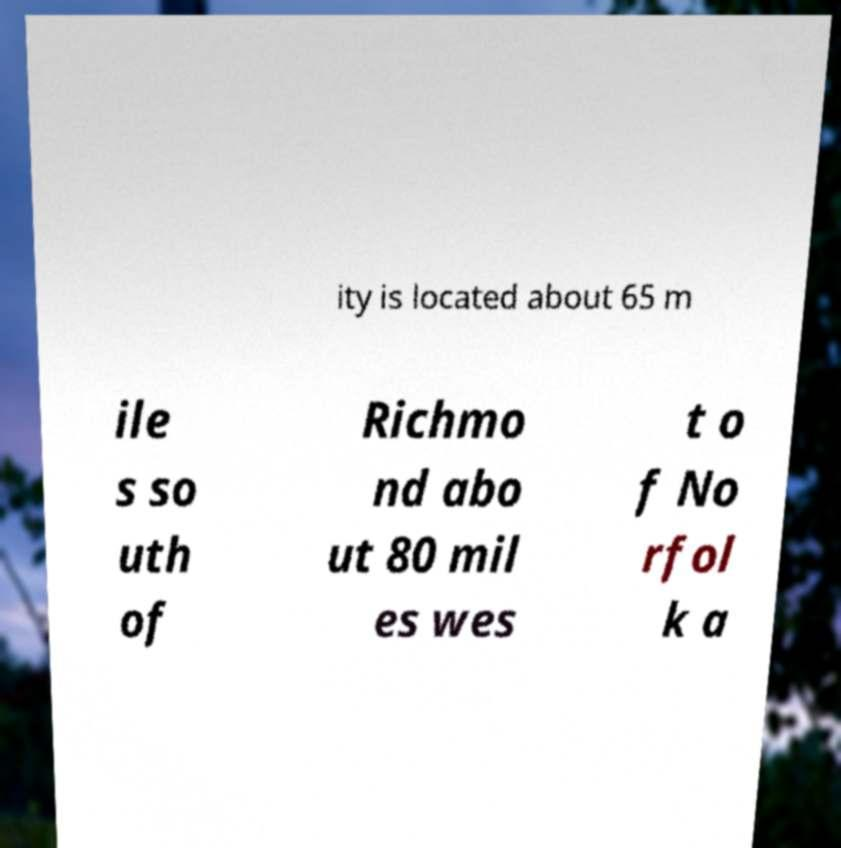What messages or text are displayed in this image? I need them in a readable, typed format. ity is located about 65 m ile s so uth of Richmo nd abo ut 80 mil es wes t o f No rfol k a 